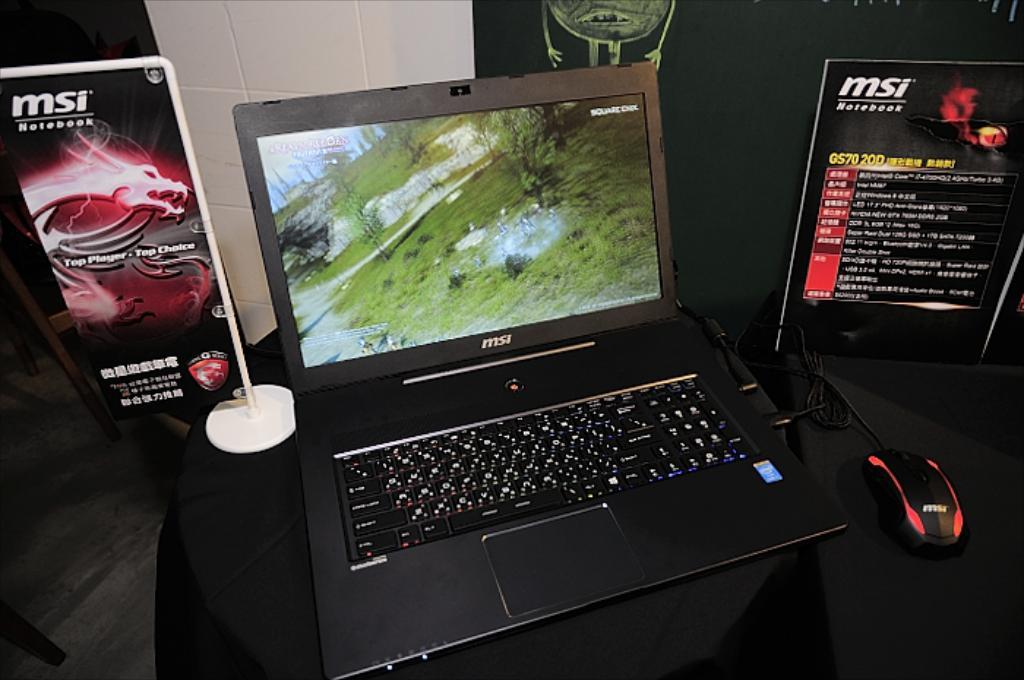<image>
Provide a brief description of the given image. A MSI brand laptop is open with a red and black mouse sitting next to it. 